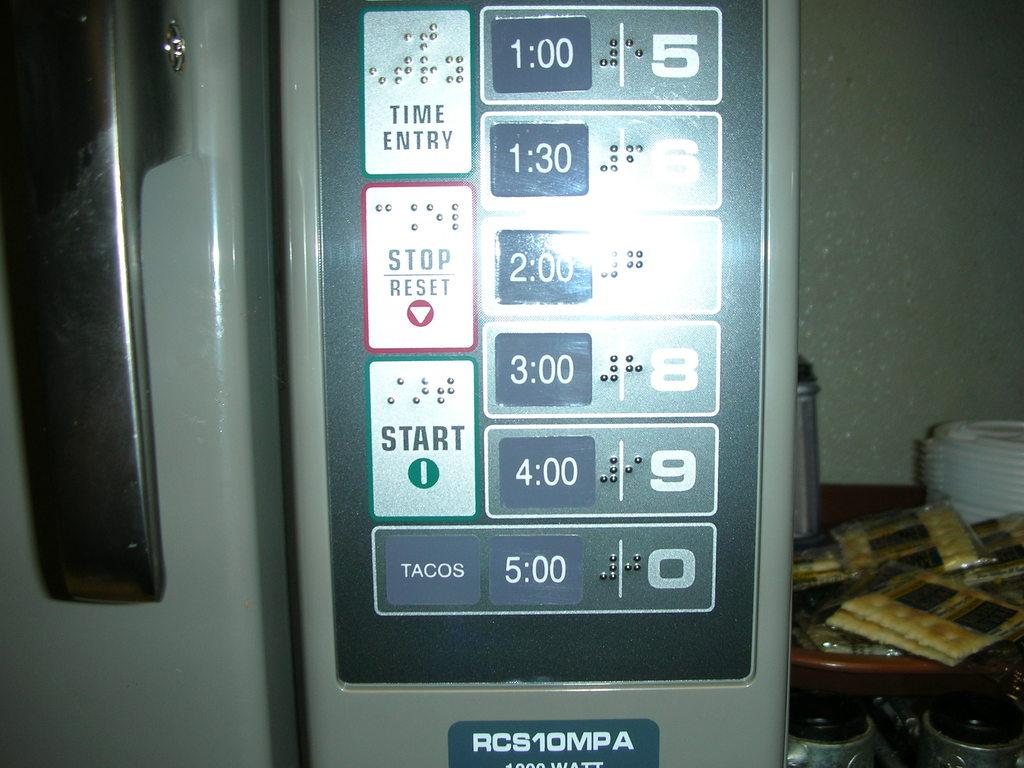<image>
Describe the image concisely. A device has the words Time Entry, amongst other things. 